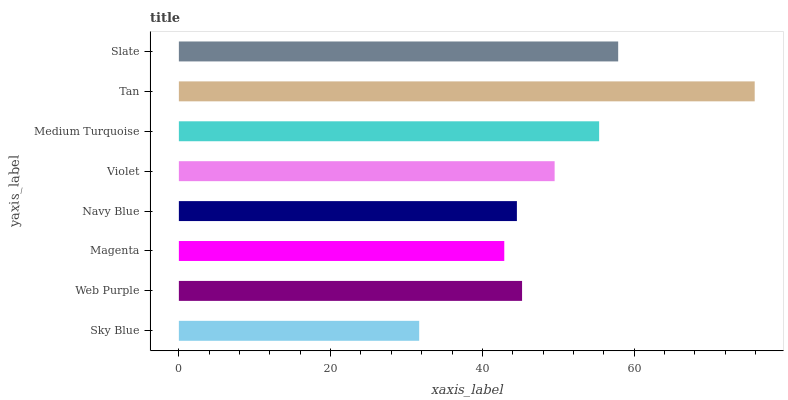Is Sky Blue the minimum?
Answer yes or no. Yes. Is Tan the maximum?
Answer yes or no. Yes. Is Web Purple the minimum?
Answer yes or no. No. Is Web Purple the maximum?
Answer yes or no. No. Is Web Purple greater than Sky Blue?
Answer yes or no. Yes. Is Sky Blue less than Web Purple?
Answer yes or no. Yes. Is Sky Blue greater than Web Purple?
Answer yes or no. No. Is Web Purple less than Sky Blue?
Answer yes or no. No. Is Violet the high median?
Answer yes or no. Yes. Is Web Purple the low median?
Answer yes or no. Yes. Is Magenta the high median?
Answer yes or no. No. Is Tan the low median?
Answer yes or no. No. 